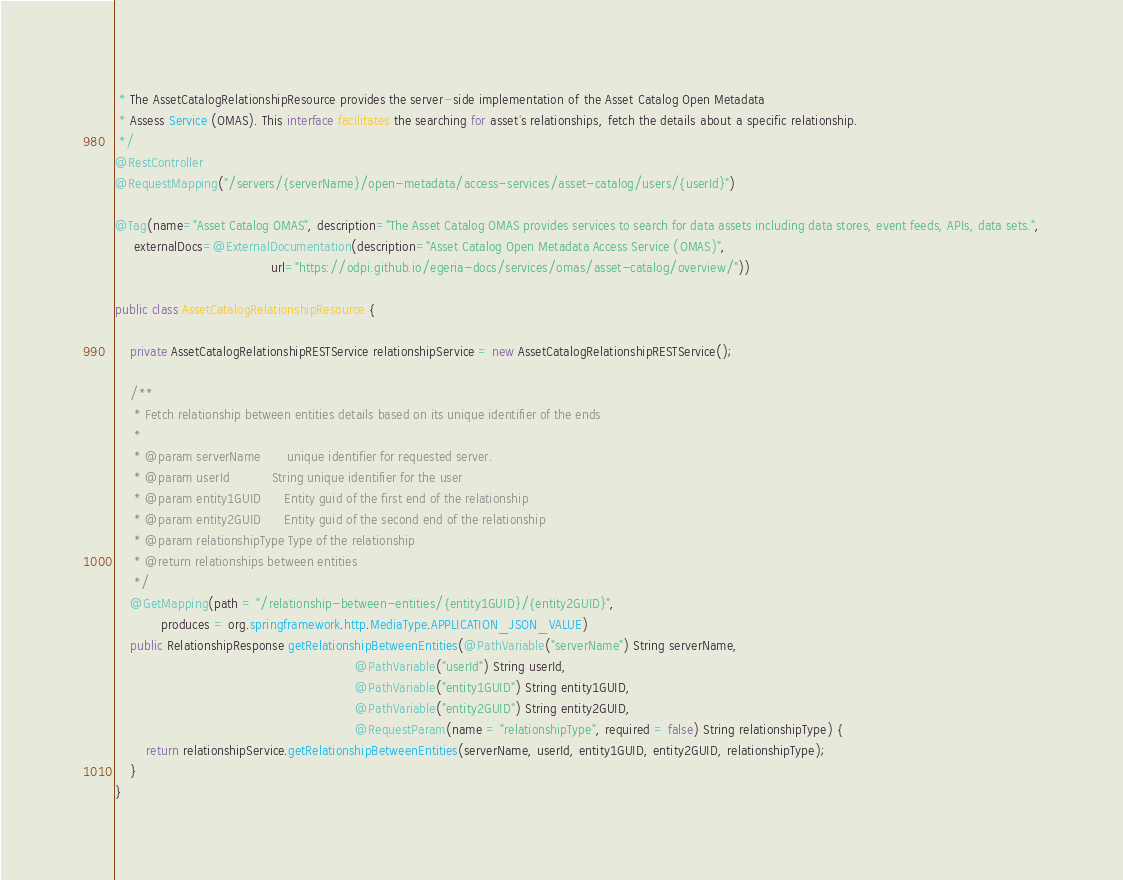<code> <loc_0><loc_0><loc_500><loc_500><_Java_> * The AssetCatalogRelationshipResource provides the server-side implementation of the Asset Catalog Open Metadata
 * Assess Service (OMAS). This interface facilitates the searching for asset's relationships, fetch the details about a specific relationship.
 */
@RestController
@RequestMapping("/servers/{serverName}/open-metadata/access-services/asset-catalog/users/{userId}")

@Tag(name="Asset Catalog OMAS", description="The Asset Catalog OMAS provides services to search for data assets including data stores, event feeds, APIs, data sets.",
     externalDocs=@ExternalDocumentation(description="Asset Catalog Open Metadata Access Service (OMAS)",
                                         url="https://odpi.github.io/egeria-docs/services/omas/asset-catalog/overview/"))

public class AssetCatalogRelationshipResource {

    private AssetCatalogRelationshipRESTService relationshipService = new AssetCatalogRelationshipRESTService();

    /**
     * Fetch relationship between entities details based on its unique identifier of the ends
     *
     * @param serverName       unique identifier for requested server.
     * @param userId           String unique identifier for the user
     * @param entity1GUID      Entity guid of the first end of the relationship
     * @param entity2GUID      Entity guid of the second end of the relationship
     * @param relationshipType Type of the relationship
     * @return relationships between entities
     */
    @GetMapping(path = "/relationship-between-entities/{entity1GUID}/{entity2GUID}",
            produces = org.springframework.http.MediaType.APPLICATION_JSON_VALUE)
    public RelationshipResponse getRelationshipBetweenEntities(@PathVariable("serverName") String serverName,
                                                               @PathVariable("userId") String userId,
                                                               @PathVariable("entity1GUID") String entity1GUID,
                                                               @PathVariable("entity2GUID") String entity2GUID,
                                                               @RequestParam(name = "relationshipType", required = false) String relationshipType) {
        return relationshipService.getRelationshipBetweenEntities(serverName, userId, entity1GUID, entity2GUID, relationshipType);
    }
}
</code> 